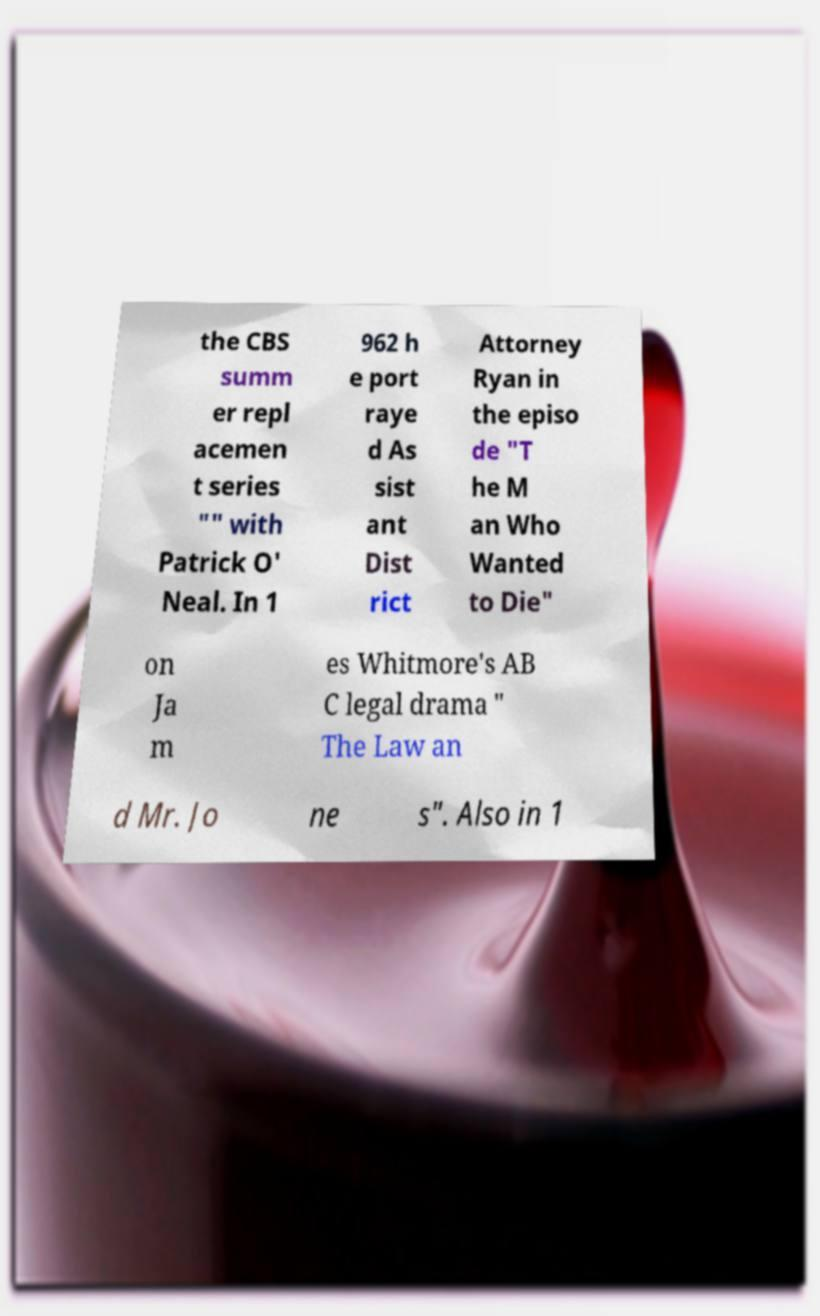Can you accurately transcribe the text from the provided image for me? the CBS summ er repl acemen t series "" with Patrick O' Neal. In 1 962 h e port raye d As sist ant Dist rict Attorney Ryan in the episo de "T he M an Who Wanted to Die" on Ja m es Whitmore's AB C legal drama " The Law an d Mr. Jo ne s". Also in 1 